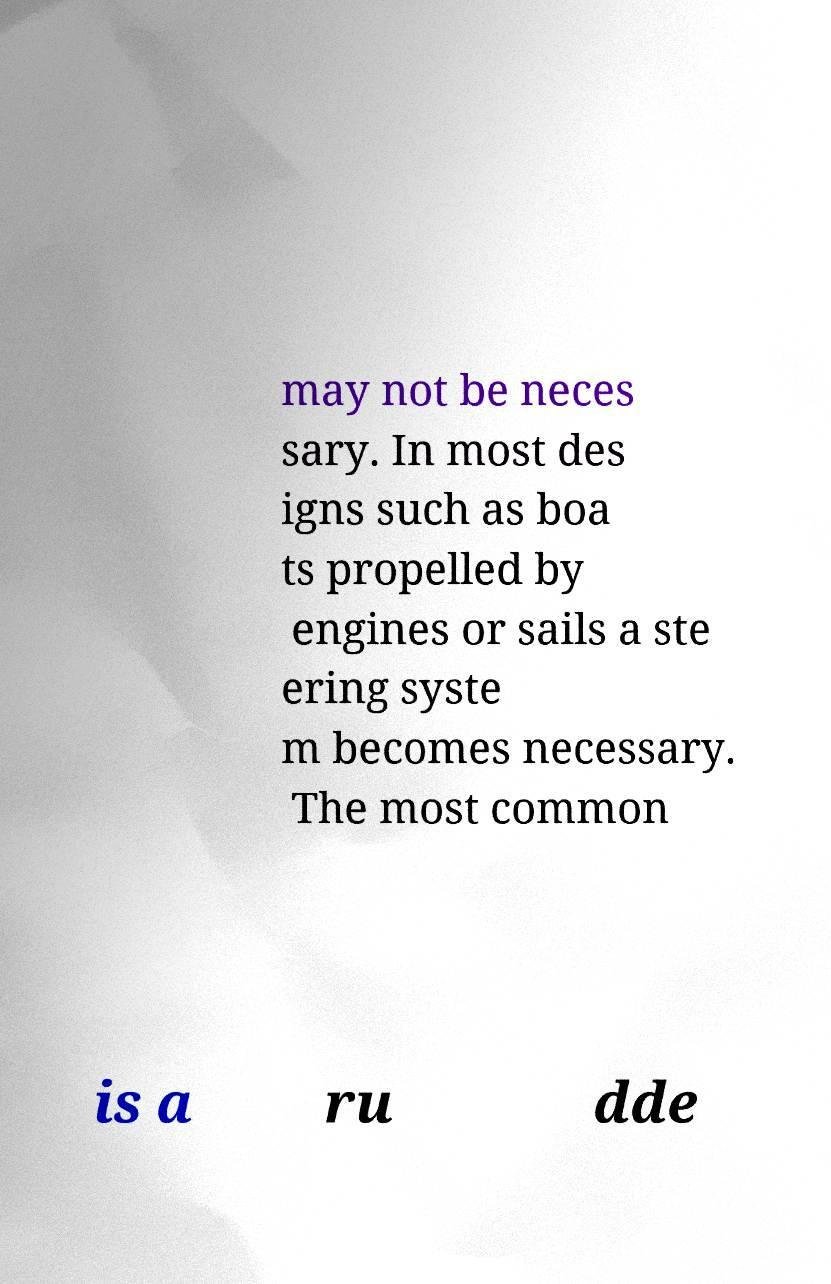Can you read and provide the text displayed in the image?This photo seems to have some interesting text. Can you extract and type it out for me? may not be neces sary. In most des igns such as boa ts propelled by engines or sails a ste ering syste m becomes necessary. The most common is a ru dde 